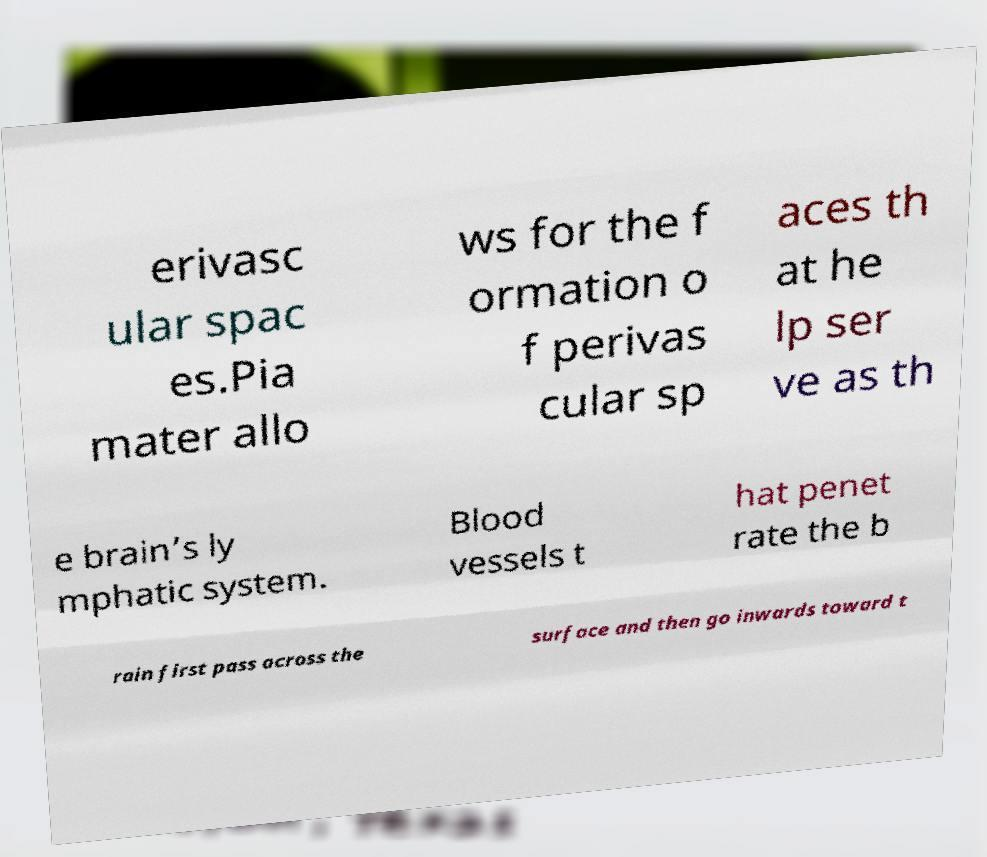There's text embedded in this image that I need extracted. Can you transcribe it verbatim? erivasc ular spac es.Pia mater allo ws for the f ormation o f perivas cular sp aces th at he lp ser ve as th e brain’s ly mphatic system. Blood vessels t hat penet rate the b rain first pass across the surface and then go inwards toward t 